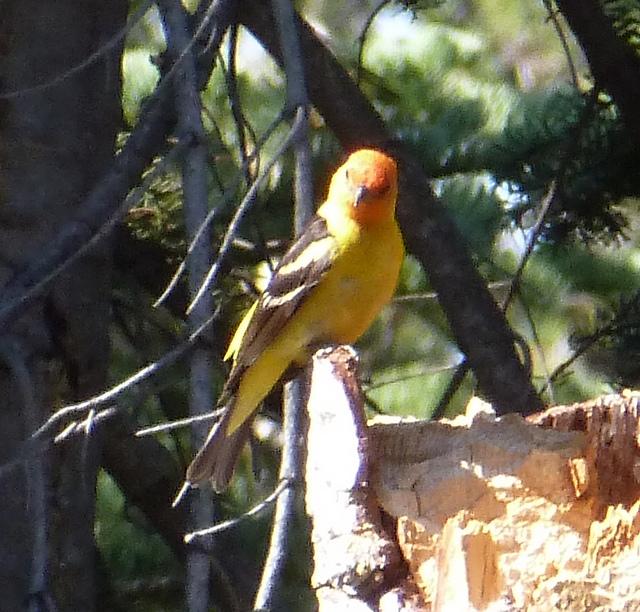Is this a pretty bird?
Quick response, please. Yes. Can this bird sing?
Quick response, please. Yes. What is your name?
Write a very short answer. Bird. 